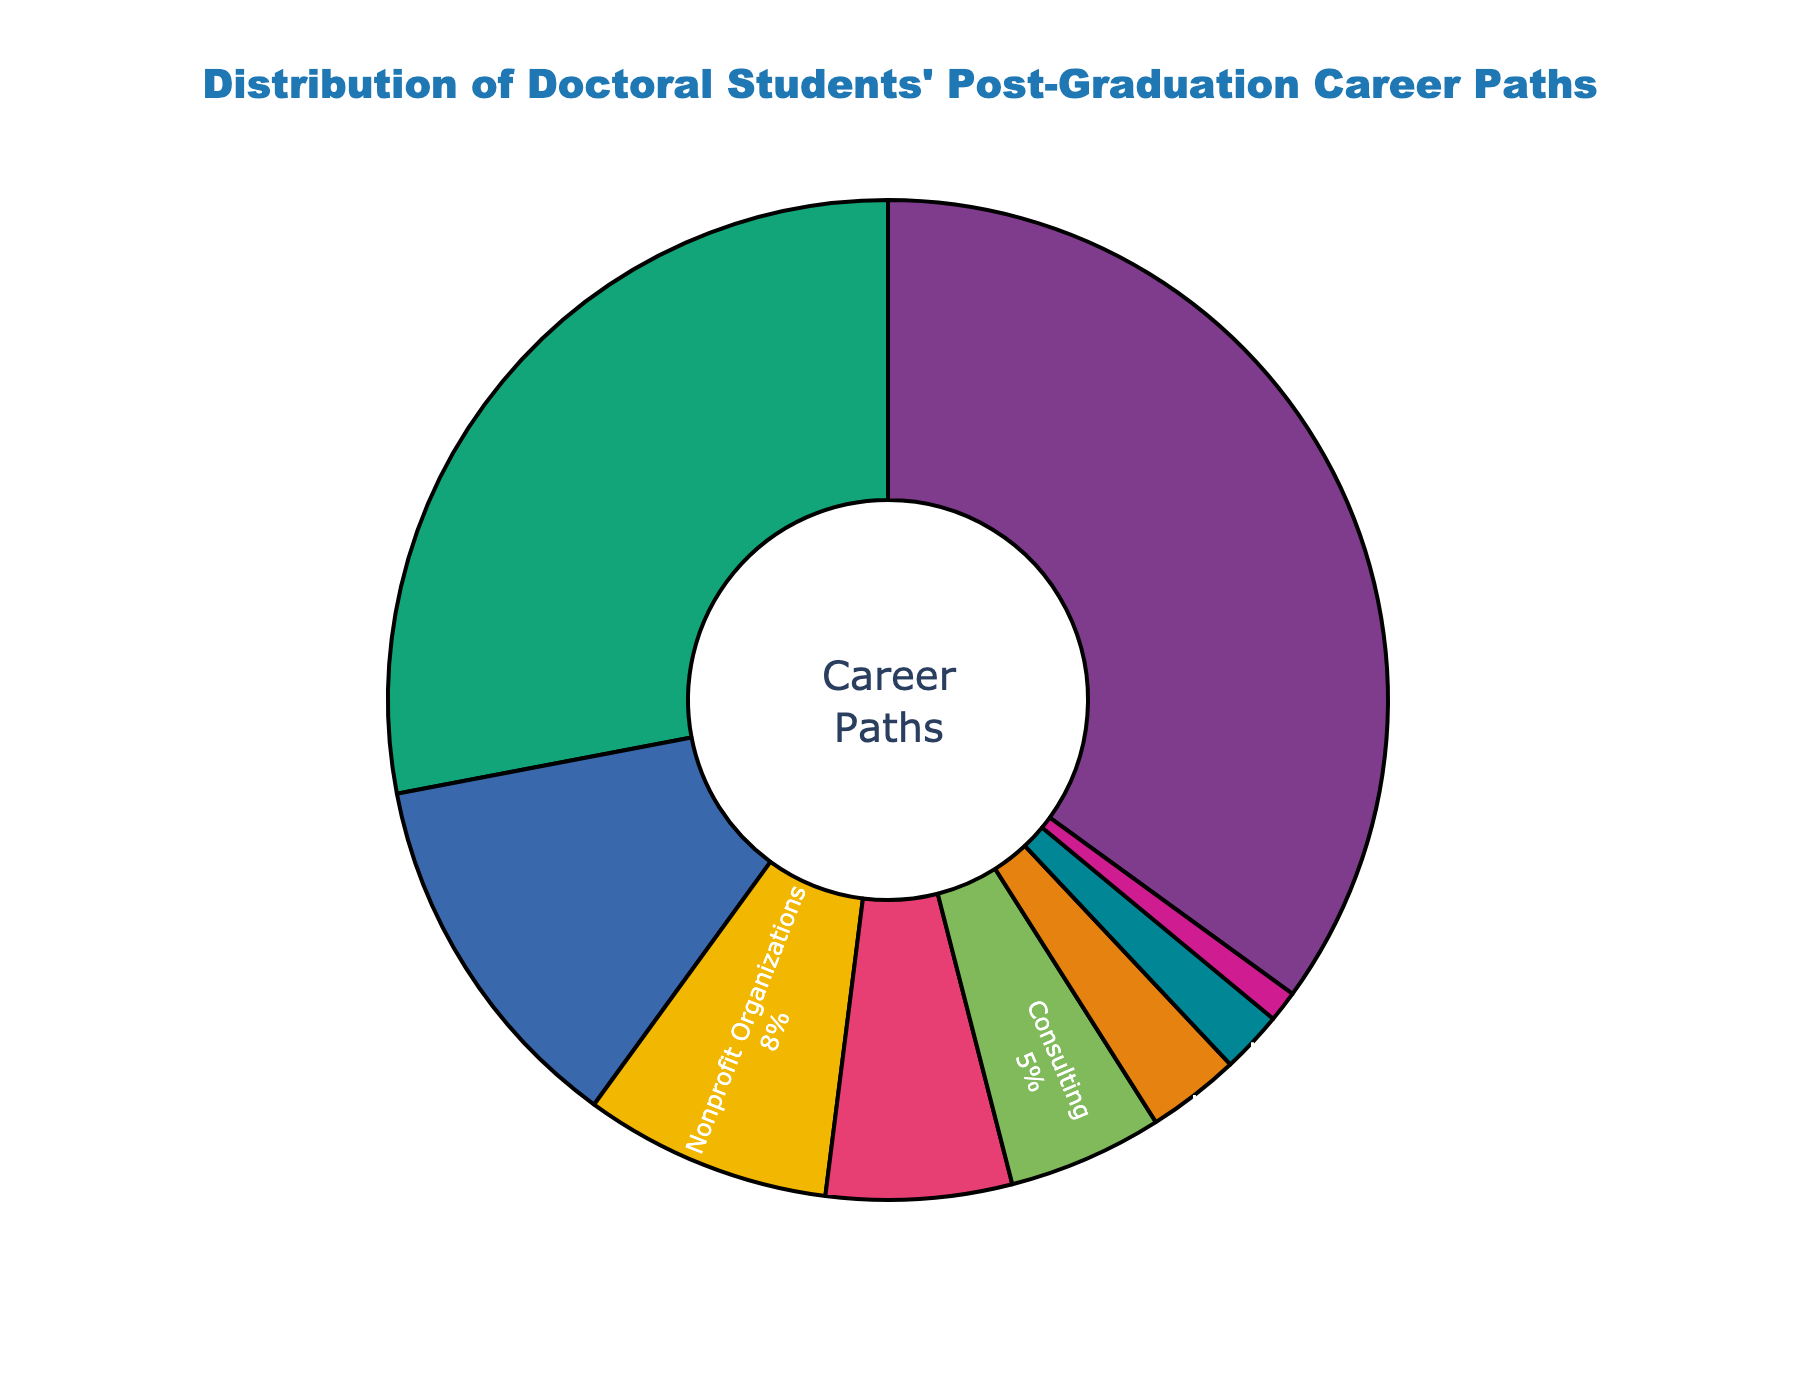What's the most common post-graduation career path for doctoral students? The figure shows different career paths along with their percentages. The career path with the highest percentage will be the most common. According to the figure, "Academia (Research/Teaching)" has the highest percentage at 35%.
Answer: Academia (Research/Teaching) How does the percentage of students going into Industry Research & Development compare with those going into Government/Public Sector? Look at the percentages for "Industry Research & Development" and "Government/Public Sector". The figure shows "Industry Research & Development" at 28% and "Government/Public Sector" at 12%. Therefore, more students go into Industry Research & Development.
Answer: More Which career path is the least common among doctoral students? Find the career path with the smallest percentage in the figure. "Science Communication/Journalism" has the smallest percentage at 1%.
Answer: Science Communication/Journalism What's the combined percentage of students pursuing careers in Healthcare/Medical Practice and Corporate Management? Add the percentages of "Healthcare/Medical Practice" and "Corporate Management". The figure shows 3% for Healthcare/Medical Practice and 2% for Corporate Management. The combined percentage is 3% + 2% = 5%.
Answer: 5% Is the percentage of students going into Nonprofit Organizations greater than those going into Entrepreneurship/Startups? Compare the percentages of "Nonprofit Organizations" and "Entrepreneurship/Startups". The figure shows "Nonprofit Organizations" at 8% and "Entrepreneurship/Startups" at 6%. Therefore, the percentage of students joining Nonprofit Organizations is greater.
Answer: Greater What is the percentage difference between Academia (Research/Teaching) and Consulting? Subtract the percentage of "Consulting" from "Academia (Research/Teaching)". The figure shows 35% for Academia and 5% for Consulting, so the difference is 35% - 5% = 30%.
Answer: 30% How many more students pursue Industry Research & Development compared to Consulting, given the percentages? Subtract the percentage of "Consulting" from "Industry Research & Development". The figure shows 28% for Industry Research & Development and 5% for Consulting. The difference is 28% - 5% = 23%.
Answer: 23% Which career paths have less than 10% of students pursuing them? Identify career paths with percentages below 10%. According to the figure, these are "Nonprofit Organizations" (8%), "Entrepreneurship/Startups" (6%), "Consulting" (5%), "Healthcare/Medical Practice" (3%), "Corporate Management" (2%), and "Science Communication/Journalism" (1%).
Answer: Nonprofit Organizations, Entrepreneurship/Startups, Consulting, Healthcare/Medical Practice, Corporate Management, Science Communication/Journalism 